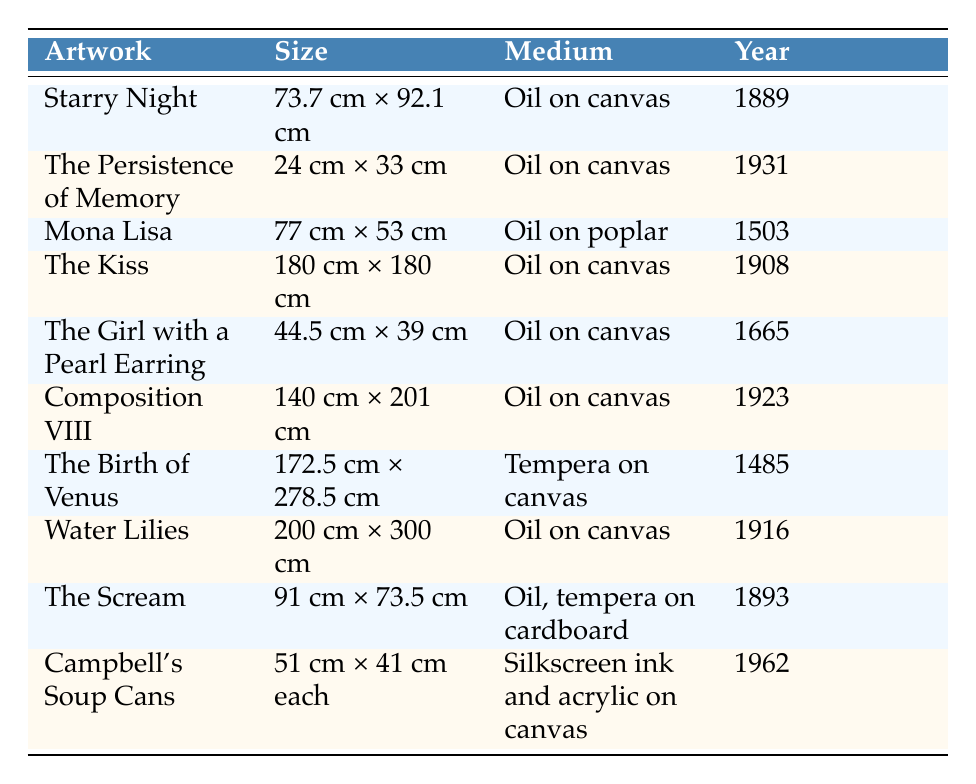What is the size of "The Girl with a Pearl Earring"? The table lists "The Girl with a Pearl Earring" and shows its size in the corresponding column, which is 44.5 cm × 39 cm.
Answer: 44.5 cm × 39 cm Which artwork has the largest size? By comparing the sizes in the table, "Water Lilies" is the largest at 200 cm × 300 cm, exceeding the dimensions of all other artworks listed.
Answer: Water Lilies Is "The Persistence of Memory" older than "The Birth of Venus"? The table provides the completion years for both artworks: "The Persistence of Memory" was completed in 1931 and "The Birth of Venus" in 1485. Since 1485 is earlier than 1931, "The Birth of Venus" is indeed older.
Answer: No What is the most recent artwork completed in the collection? Looking at the years provided in the table, the artwork with the most recent completion year is "Campbell's Soup Cans," which was completed in 1962.
Answer: Campbell's Soup Cans How many artworks were completed in the 19th century? The artworks completed in the 19th century are "Starry Night" (1889), "The Scream" (1893), and "The Birth of Venus" (1885). Thus, there are a total of 3 artworks from the 19th century.
Answer: 3 What is the average size (in area) of the artworks listed in the table? To calculate the average size, first find the area of each artwork by multiplying width by height (after converting sizes to a consistent unit if necessary). The total area is calculated as follows: (73.7*92.1) + (24*33) + (77*53) + (180*180) + (44.5*39) + (140*201) + (172.5*278.5) + (200*300) + (91*73.5) + (51*41) = 33,229.72 sq.cm. Then divide by the 10 artworks to find the average area: 33,229.72 / 10 = 3,322.972 sq.cm.
Answer: 3,322.972 sq.cm Is there any artwork created using tempera? By checking the medium column of the table, "The Birth of Venus" is noted as using tempera on canvas. Thus, it can be confirmed that there is at least one artwork that uses tempera.
Answer: Yes Which artist created the second smallest artwork in terms of dimensions? First, identify the smallest artworks by measuring their area and comparing. The second smallest is "The Persistence of Memory" (24 cm × 33 cm), which ranks just above "The Girl with a Pearl Earring." Therefore, the artist of this piece is Salvador Dalí.
Answer: Salvador Dalí 